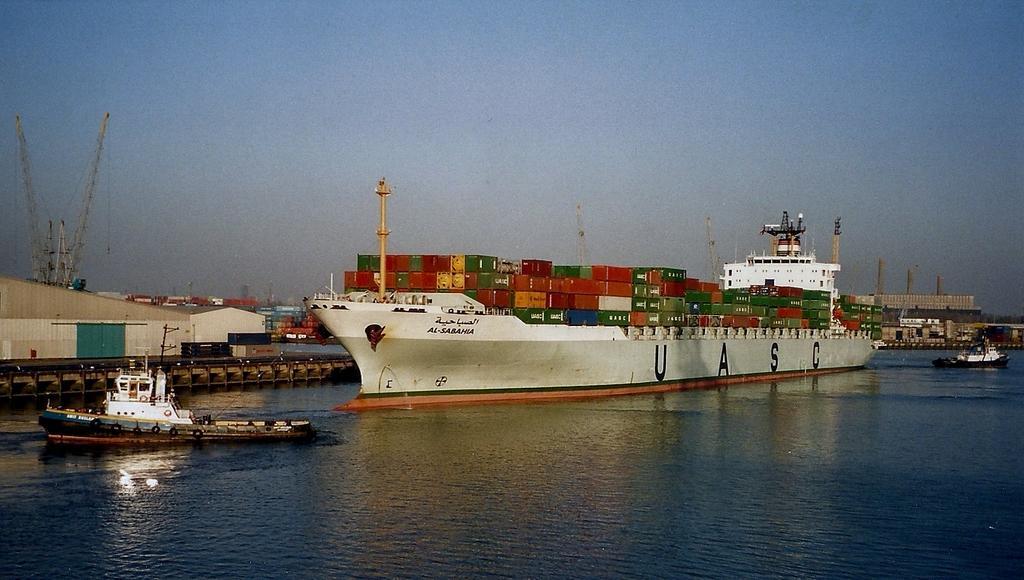In one or two sentences, can you explain what this image depicts? In this image I can see the boats and ships on the water. I can see many containers in one of the ship. In the background I can see the buildings, cranes and the blue sky. 